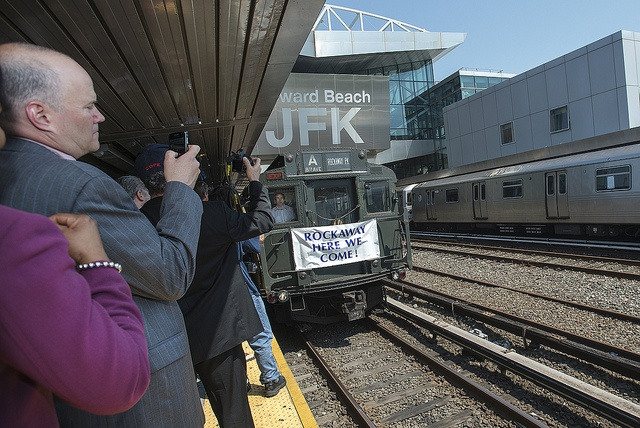Describe the objects in this image and their specific colors. I can see train in black, gray, darkgray, and white tones, people in black, gray, darkgray, and darkblue tones, people in black and purple tones, people in black and gray tones, and train in black, purple, and gray tones in this image. 